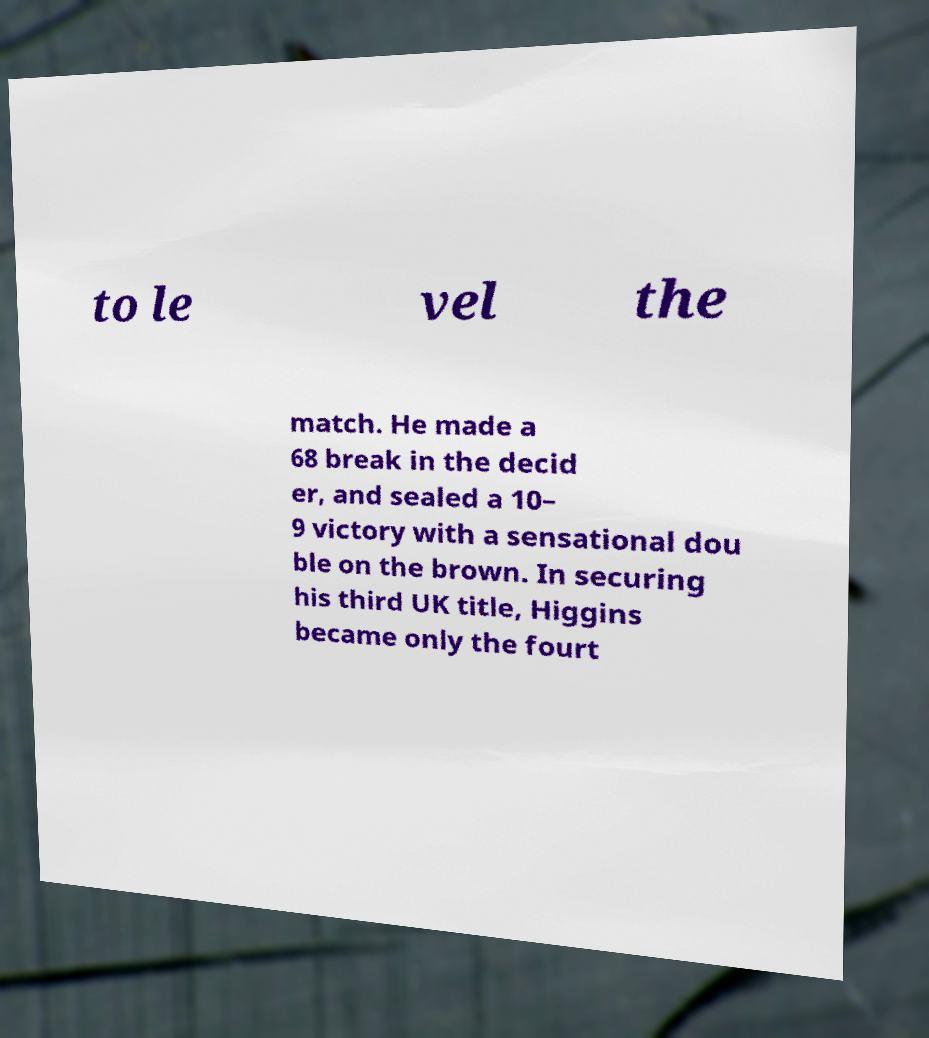Could you extract and type out the text from this image? to le vel the match. He made a 68 break in the decid er, and sealed a 10– 9 victory with a sensational dou ble on the brown. In securing his third UK title, Higgins became only the fourt 